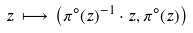Convert formula to latex. <formula><loc_0><loc_0><loc_500><loc_500>z \, \longmapsto \, \left ( \pi ^ { \circ } ( z ) ^ { - 1 } \cdot z , \pi ^ { \circ } ( z ) \right )</formula> 